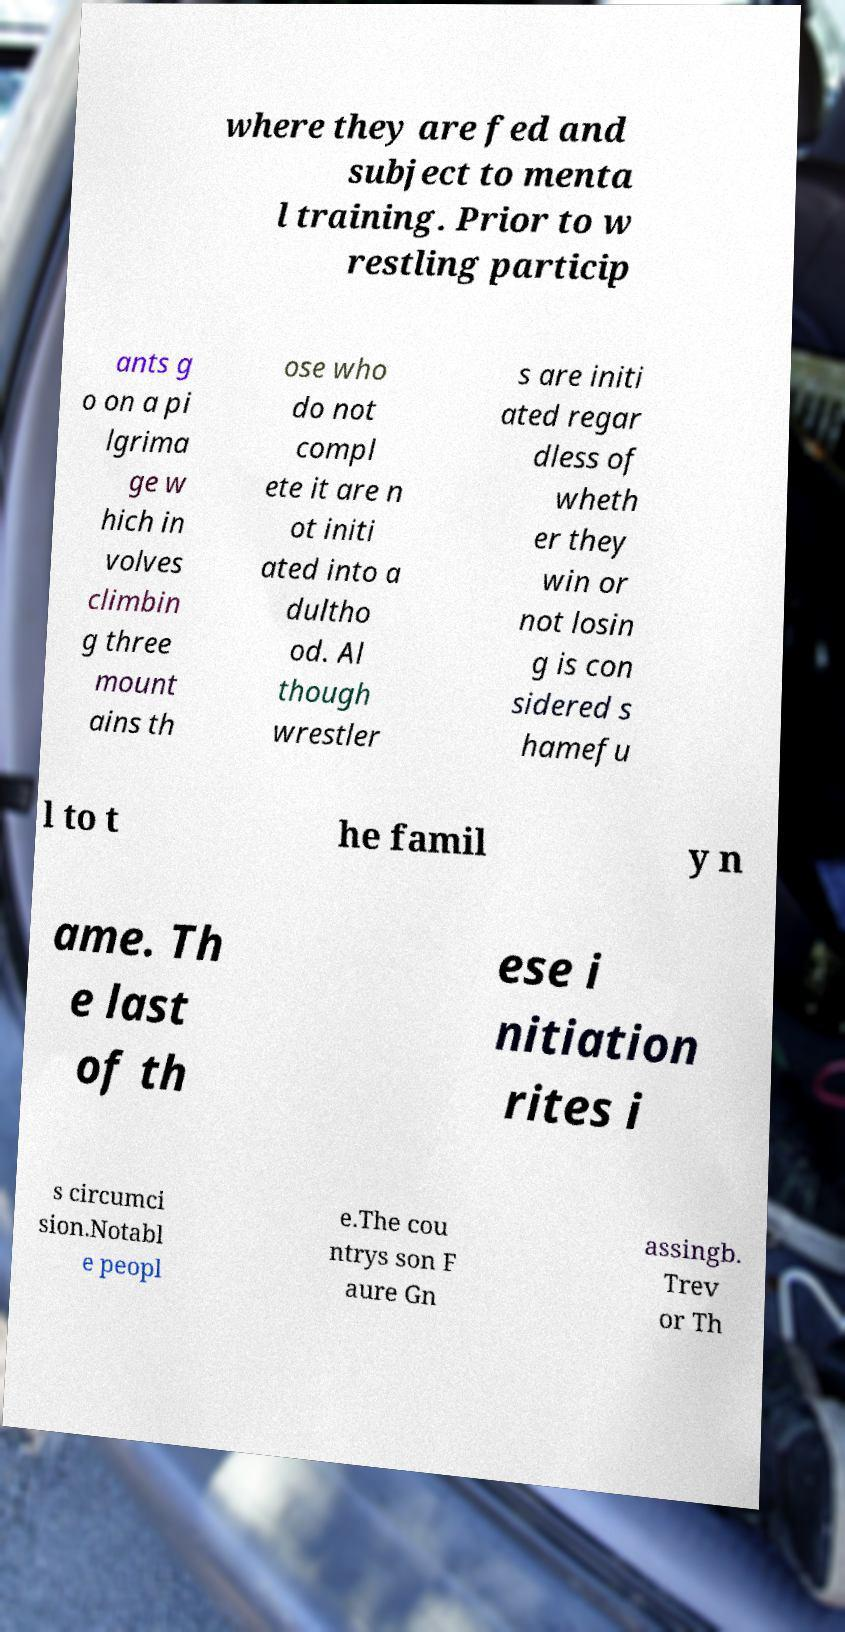For documentation purposes, I need the text within this image transcribed. Could you provide that? where they are fed and subject to menta l training. Prior to w restling particip ants g o on a pi lgrima ge w hich in volves climbin g three mount ains th ose who do not compl ete it are n ot initi ated into a dultho od. Al though wrestler s are initi ated regar dless of wheth er they win or not losin g is con sidered s hamefu l to t he famil y n ame. Th e last of th ese i nitiation rites i s circumci sion.Notabl e peopl e.The cou ntrys son F aure Gn assingb. Trev or Th 